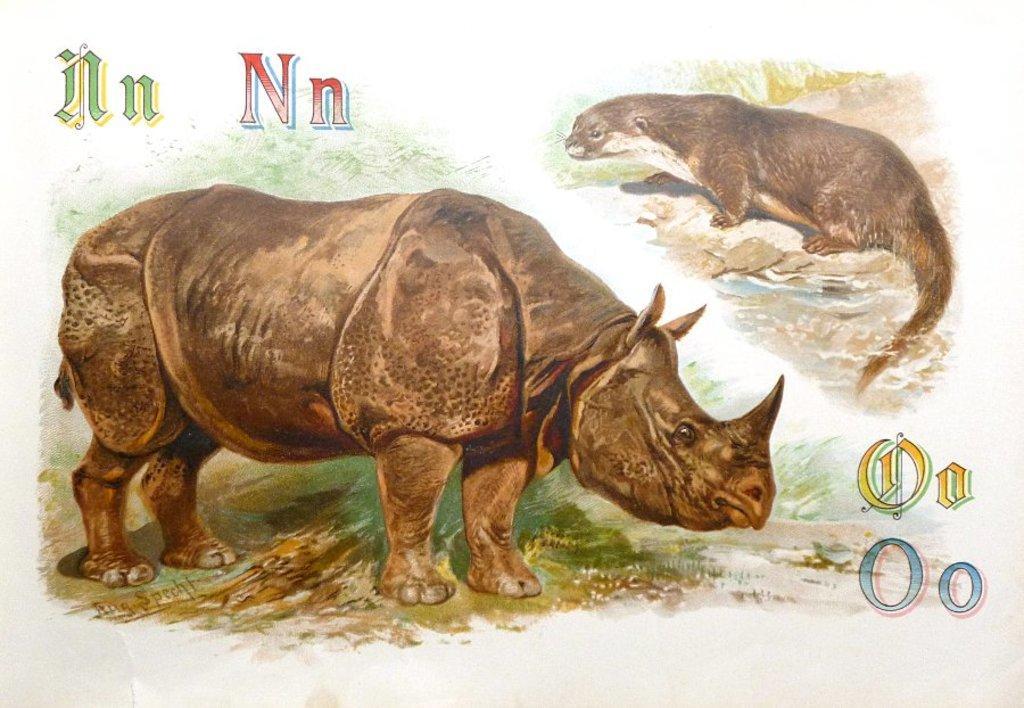Please provide a concise description of this image. This image consists of a poster with an image of a rhinoceros and an animal. There is a text on this poster. 